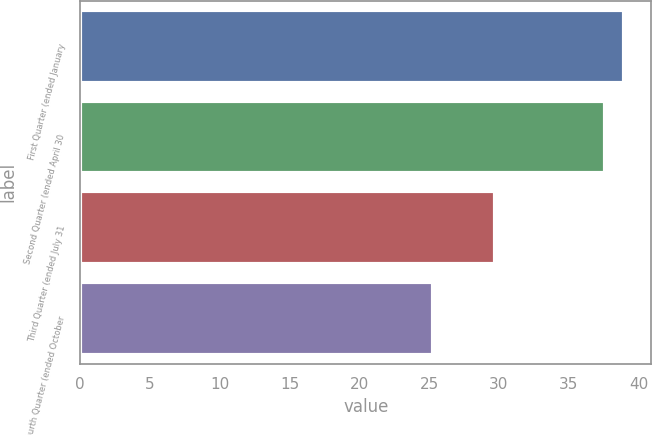Convert chart to OTSL. <chart><loc_0><loc_0><loc_500><loc_500><bar_chart><fcel>First Quarter (ended January<fcel>Second Quarter (ended April 30<fcel>Third Quarter (ended July 31<fcel>Fourth Quarter (ended October<nl><fcel>38.97<fcel>37.62<fcel>29.68<fcel>25.31<nl></chart> 